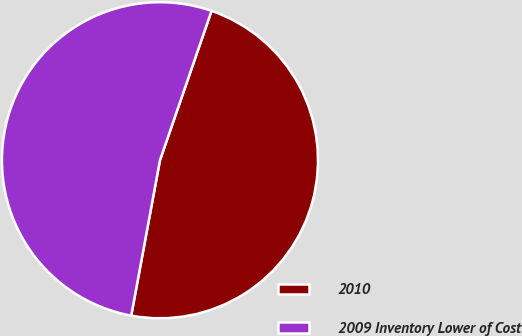Convert chart to OTSL. <chart><loc_0><loc_0><loc_500><loc_500><pie_chart><fcel>2010<fcel>2009 Inventory Lower of Cost<nl><fcel>47.62%<fcel>52.38%<nl></chart> 